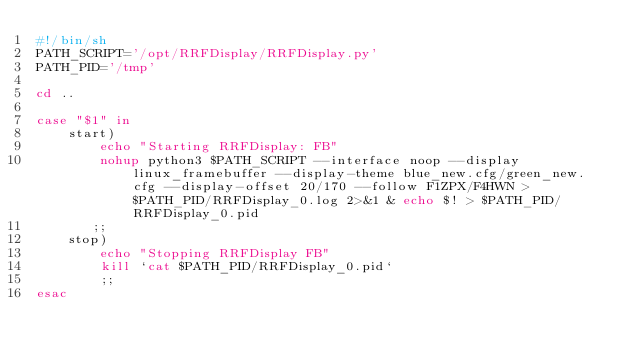Convert code to text. <code><loc_0><loc_0><loc_500><loc_500><_Bash_>#!/bin/sh
PATH_SCRIPT='/opt/RRFDisplay/RRFDisplay.py'
PATH_PID='/tmp'

cd ..

case "$1" in
    start)
        echo "Starting RRFDisplay: FB"
        nohup python3 $PATH_SCRIPT --interface noop --display linux_framebuffer --display-theme blue_new.cfg/green_new.cfg --display-offset 20/170 --follow F1ZPX/F4HWN > $PATH_PID/RRFDisplay_0.log 2>&1 & echo $! > $PATH_PID/RRFDisplay_0.pid
       ;;
    stop) 
        echo "Stopping RRFDisplay FB"
        kill `cat $PATH_PID/RRFDisplay_0.pid`
        ;;
esac</code> 